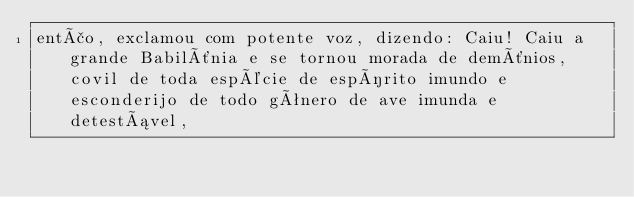Convert code to text. <code><loc_0><loc_0><loc_500><loc_500><_HTML_>então, exclamou com potente voz, dizendo: Caiu! Caiu a grande Babilônia e se tornou morada de demônios, covil de toda espécie de espírito imundo e esconderijo de todo gênero de ave imunda e detestável,</code> 